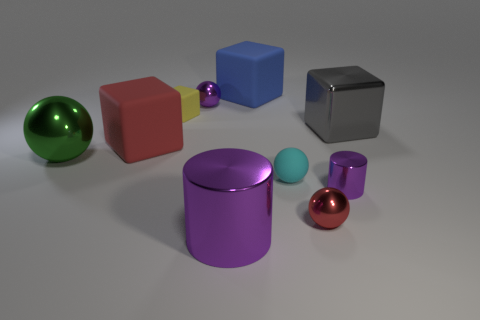Can you describe the arrangement of objects in terms of their proximity to each other? Certainly. We have a cluster of larger objects positioned centrally and towards the front, comprising a purple cylindrical container, a red cube, and a green shiny sphere. Behind this main cluster are smaller items: a cyan sphere, a red shiny sphere, and a smaller blue cube. Several objects are slightly isolated from the rest, such as the grey cube and the yellow rubber object which are to the right and left of the main group respectively, creating a semi-spread out arrangement. 